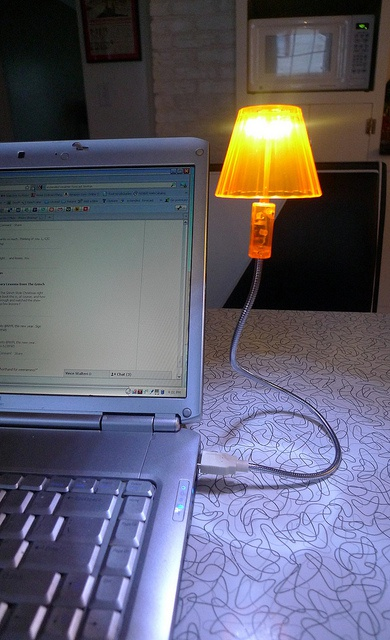Describe the objects in this image and their specific colors. I can see laptop in black, gray, darkgray, and navy tones and microwave in black and gray tones in this image. 